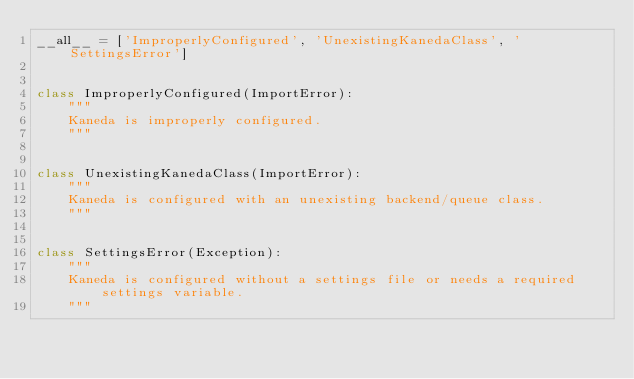Convert code to text. <code><loc_0><loc_0><loc_500><loc_500><_Python_>__all__ = ['ImproperlyConfigured', 'UnexistingKanedaClass', 'SettingsError']


class ImproperlyConfigured(ImportError):
    """
    Kaneda is improperly configured.
    """


class UnexistingKanedaClass(ImportError):
    """
    Kaneda is configured with an unexisting backend/queue class.
    """


class SettingsError(Exception):
    """
    Kaneda is configured without a settings file or needs a required settings variable.
    """
</code> 